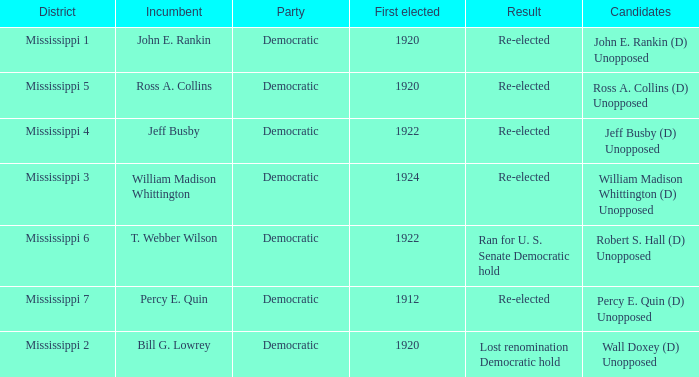What was the result of the election featuring william madison whittington? Re-elected. 